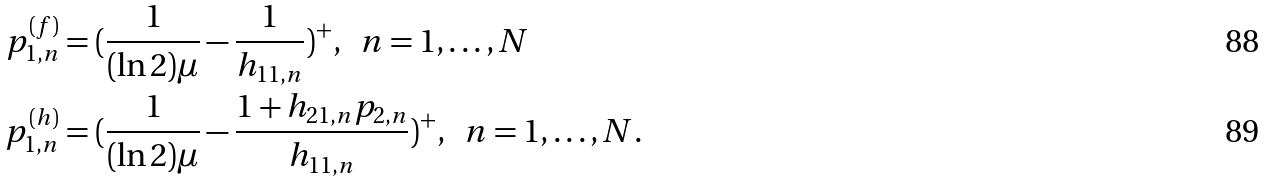<formula> <loc_0><loc_0><loc_500><loc_500>p _ { 1 , n } ^ { ( f ) } & = ( \frac { 1 } { ( \ln 2 ) \mu } - \frac { 1 } { h _ { 1 1 , n } } ) ^ { + } , \ \ n = 1 , \dots , N \\ p _ { 1 , n } ^ { ( h ) } & = ( \frac { 1 } { ( \ln 2 ) \mu } - \frac { 1 + h _ { 2 1 , n } p _ { 2 , n } } { h _ { 1 1 , n } } ) ^ { + } , \ \ n = 1 , \dots , N .</formula> 